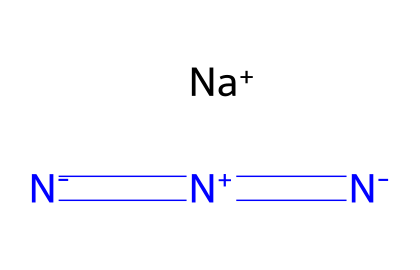What is the formula of sodium azide? The SMILES representation gives us the elements present: sodium (Na), nitrogen (N). The arrangement indicates one sodium atom and three nitrogen atoms, which forms the chemical formula NaN3.
Answer: NaN3 How many nitrogen atoms are present? From the SMILES representation, we can identify three nitrogen atoms, indicated by the three N symbols in the structure.
Answer: three What is the charge of the sodium ion in this compound? The representation indicates [Na+] for sodium, denoting that sodium carries a positive one charge.
Answer: +1 How many total bonds are formed in the azide ion? The SMILES representation shows a linear arrangement of nitrogen atoms, with double bonds between the first two nitrogen atoms and a single bond to the third nitrogen atom. There are two double bonds and one single bond, resulting in a total of three bonds within the azide ion.
Answer: three What type of chemical compound is sodium azide? Based on its structure and the presence of the azide group (N3), sodium azide is classified as a salt.
Answer: salt What is the geometry around the nitrogen atoms in sodium azide? The nitrogen atoms in sodium azide appear to be linearly arranged, as indicated by their bonding pattern in the SMILES structure, supporting a linear geometry.
Answer: linear What property of sodium azide makes it suitable for airbag systems? Sodium azide decomposes explosively when subjected to heat, which enables rapid inflation in airbag systems upon detection of a collision.
Answer: explosive 